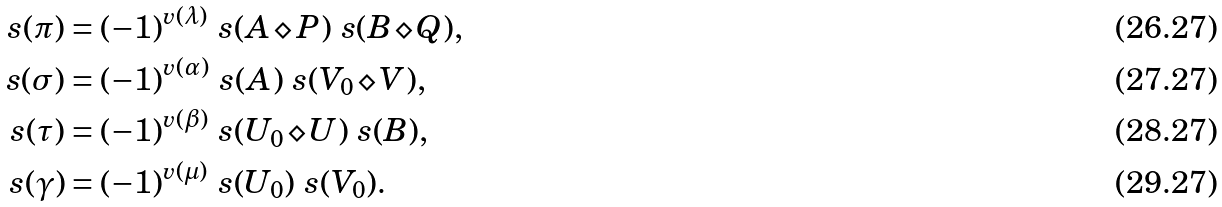Convert formula to latex. <formula><loc_0><loc_0><loc_500><loc_500>\ s ( \pi ) & = ( - 1 ) ^ { v ( \lambda ) } \ s ( A \diamond P ) \ s ( B \diamond Q ) , \\ \ s ( \sigma ) & = ( - 1 ) ^ { v ( \alpha ) } \ s ( A ) \ s ( V _ { 0 } \diamond V ) , \\ \ s ( \tau ) & = ( - 1 ) ^ { v ( \beta ) } \ s ( U _ { 0 } \diamond U ) \ s ( B ) , \\ \ s ( \gamma ) & = ( - 1 ) ^ { v ( \mu ) } \ s ( U _ { 0 } ) \ s ( V _ { 0 } ) .</formula> 